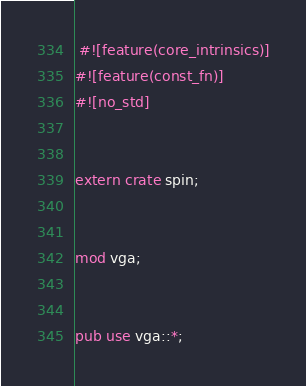Convert code to text. <code><loc_0><loc_0><loc_500><loc_500><_Rust_> #![feature(core_intrinsics)]
#![feature(const_fn)]
#![no_std]


extern crate spin;


mod vga;


pub use vga::*;
</code> 